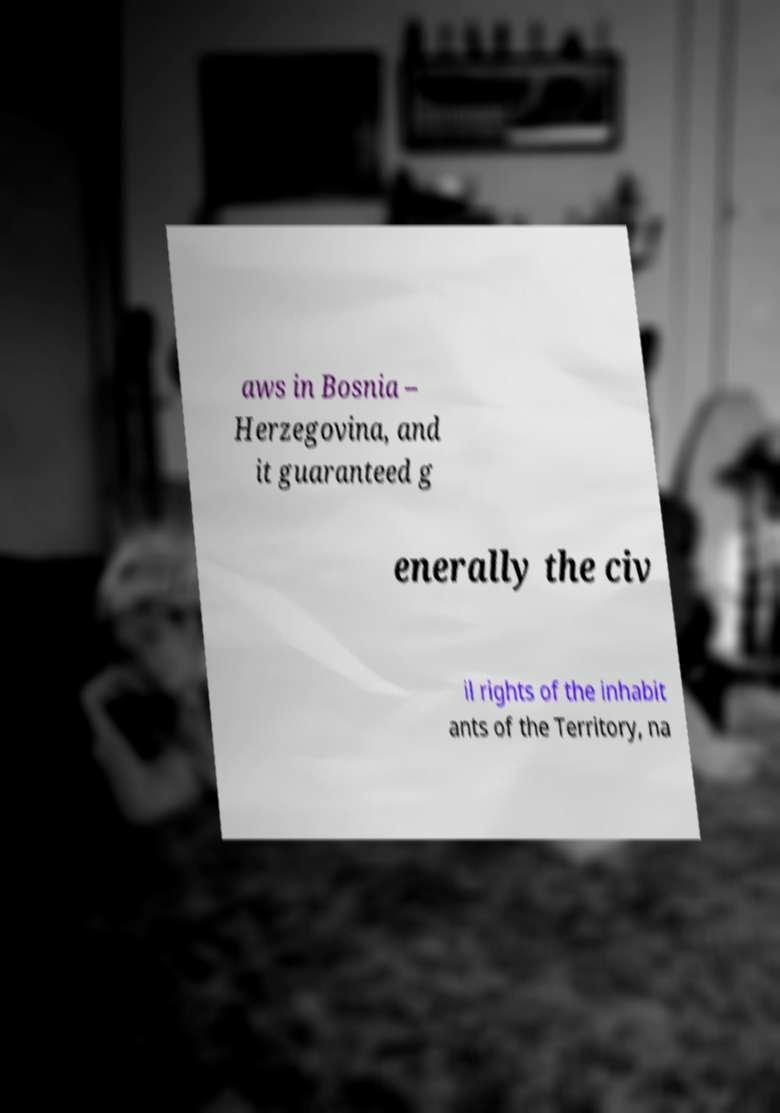Can you read and provide the text displayed in the image?This photo seems to have some interesting text. Can you extract and type it out for me? aws in Bosnia – Herzegovina, and it guaranteed g enerally the civ il rights of the inhabit ants of the Territory, na 